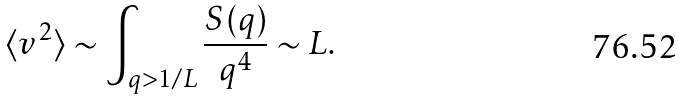<formula> <loc_0><loc_0><loc_500><loc_500>\langle v ^ { 2 } \rangle \sim \int _ { q > 1 / L } \frac { S ( { q } ) } { q ^ { 4 } } \sim L .</formula> 